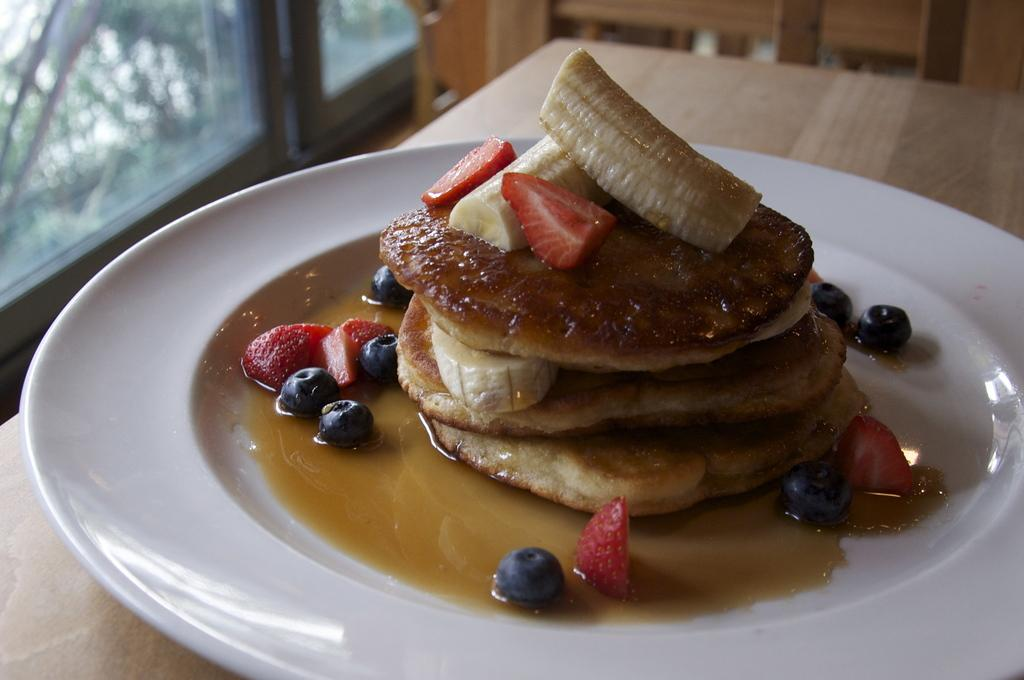What is on the plate that is visible in the image? The plate contains food, including pieces of bananas, strawberries, and grapes. Where is the plate located in the image? The plate is placed on a table. What news headline is visible on the plate in the image? There is no news headline present on the plate in the image; it contains food items. Can you see any smoke coming from the plate in the image? There is no smoke present on the plate in the image; it contains food items. 